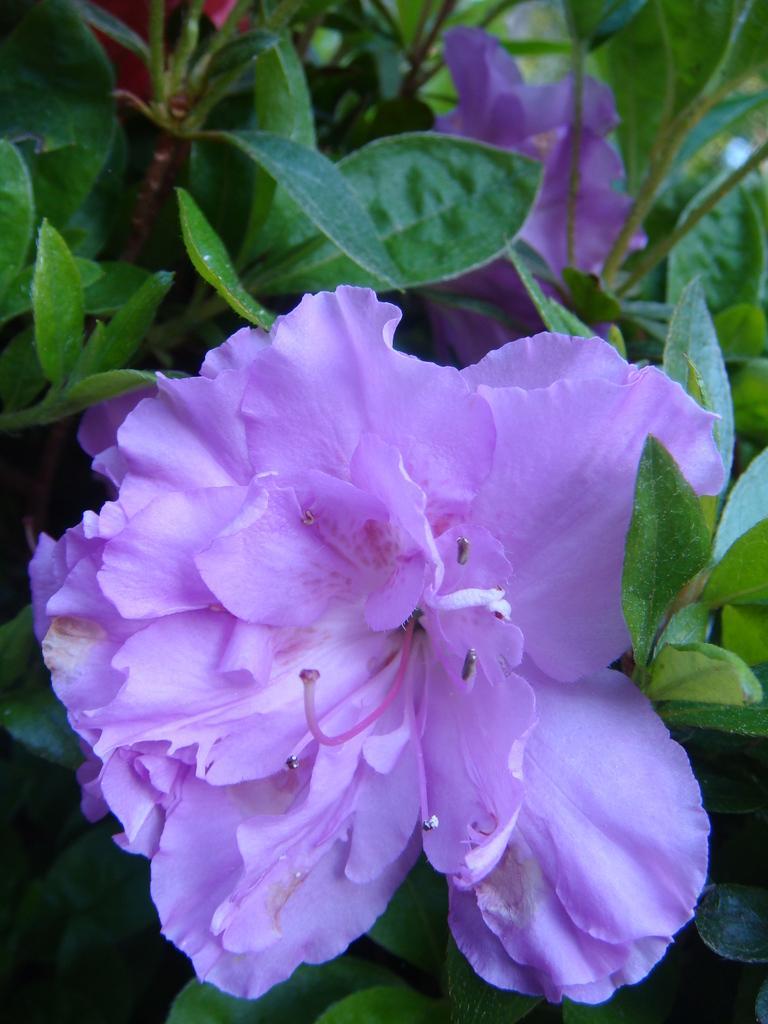Describe this image in one or two sentences. In this picture we can see flowers, leaves and stems. 